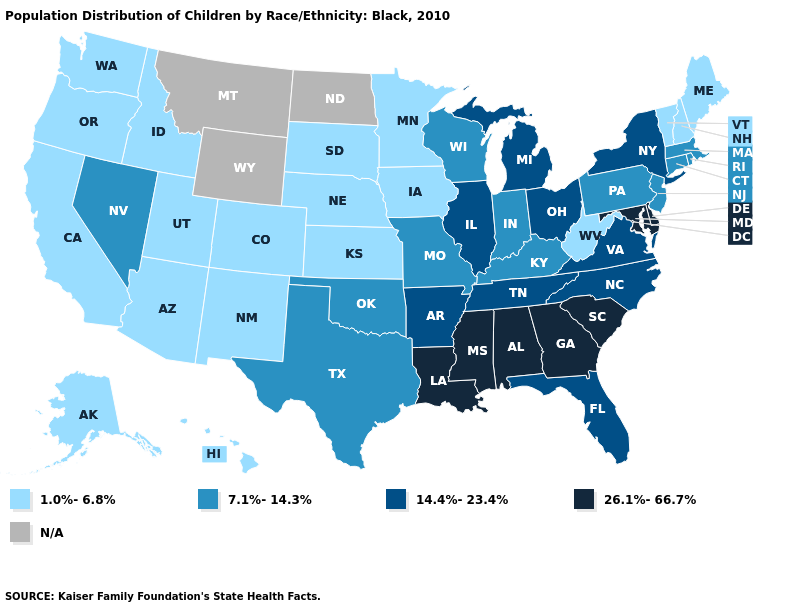Name the states that have a value in the range 14.4%-23.4%?
Concise answer only. Arkansas, Florida, Illinois, Michigan, New York, North Carolina, Ohio, Tennessee, Virginia. Which states have the lowest value in the South?
Quick response, please. West Virginia. Which states hav the highest value in the MidWest?
Give a very brief answer. Illinois, Michigan, Ohio. Does Massachusetts have the lowest value in the Northeast?
Be succinct. No. Which states have the lowest value in the Northeast?
Be succinct. Maine, New Hampshire, Vermont. What is the lowest value in the South?
Answer briefly. 1.0%-6.8%. What is the value of Iowa?
Write a very short answer. 1.0%-6.8%. What is the value of Oklahoma?
Answer briefly. 7.1%-14.3%. What is the value of Alaska?
Short answer required. 1.0%-6.8%. What is the lowest value in states that border Florida?
Quick response, please. 26.1%-66.7%. Name the states that have a value in the range 14.4%-23.4%?
Quick response, please. Arkansas, Florida, Illinois, Michigan, New York, North Carolina, Ohio, Tennessee, Virginia. What is the highest value in states that border Illinois?
Answer briefly. 7.1%-14.3%. Does the map have missing data?
Quick response, please. Yes. 